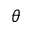Convert formula to latex. <formula><loc_0><loc_0><loc_500><loc_500>\theta</formula> 